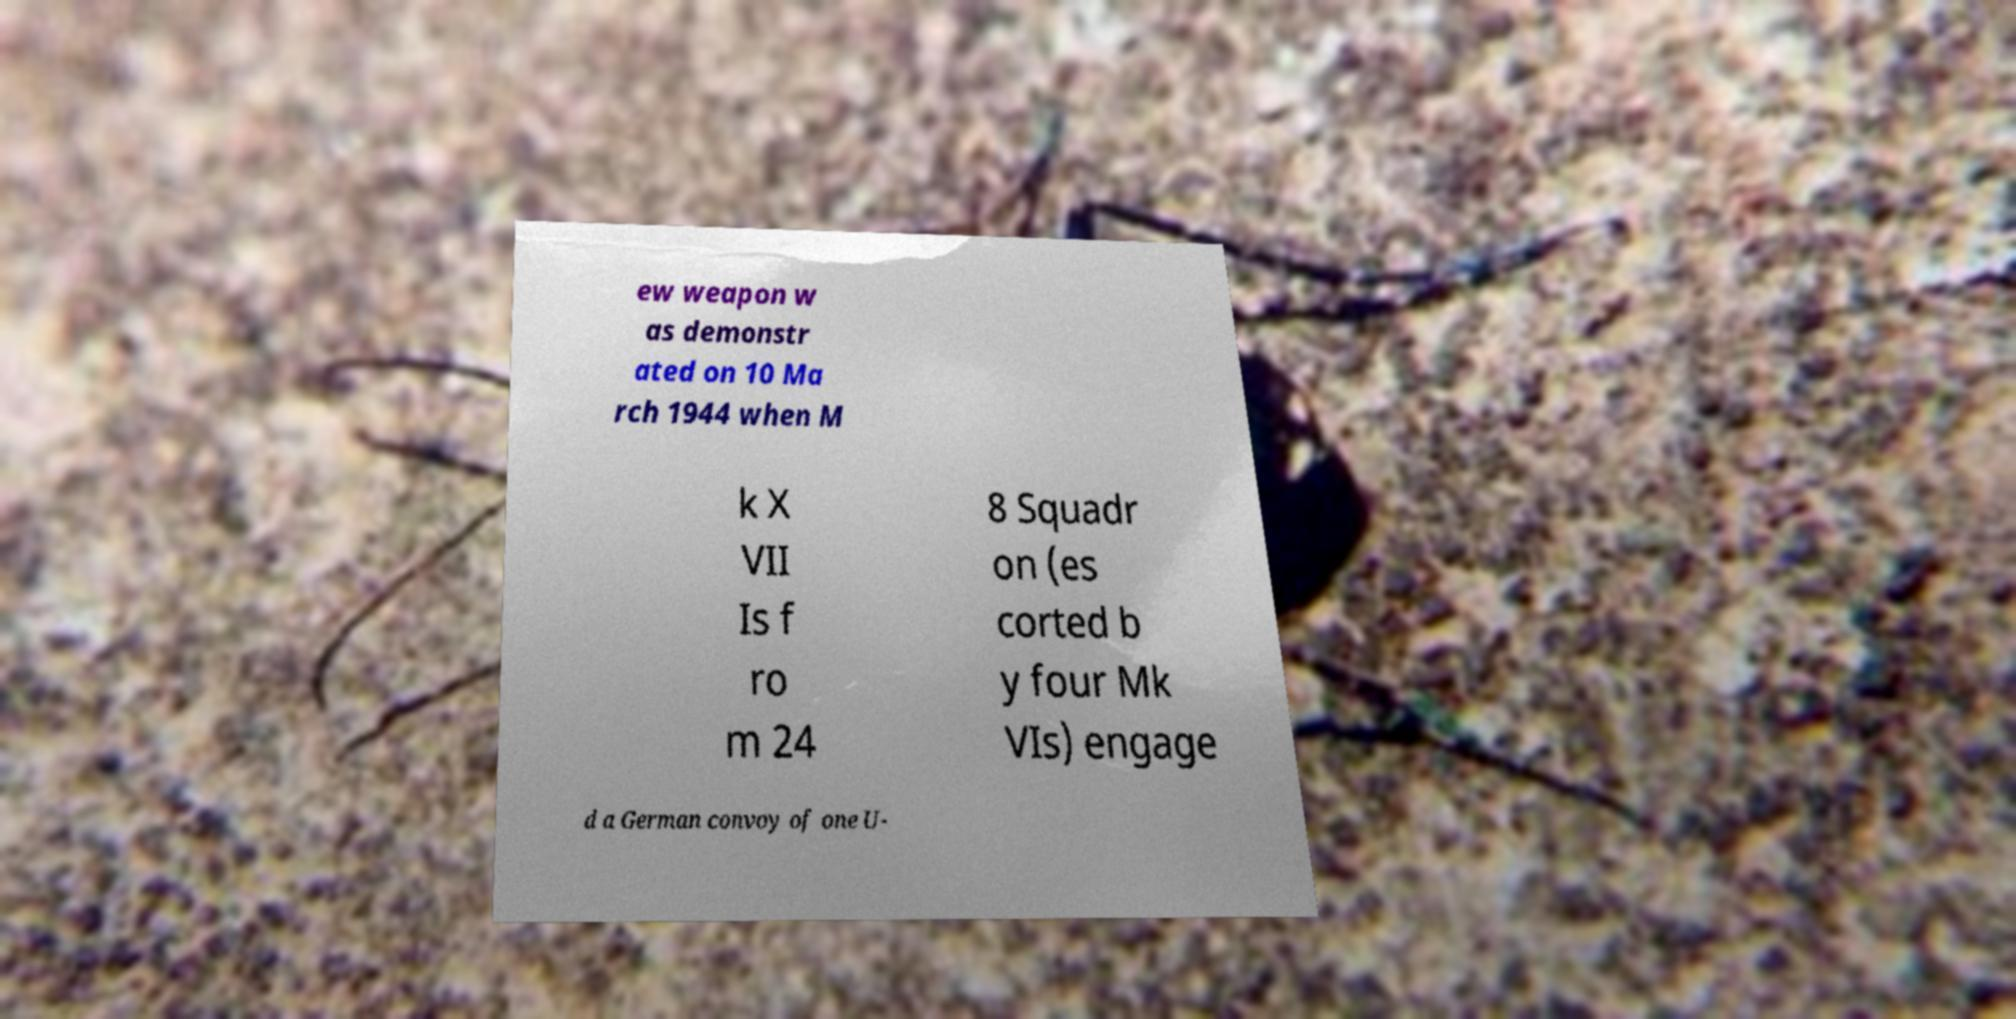There's text embedded in this image that I need extracted. Can you transcribe it verbatim? ew weapon w as demonstr ated on 10 Ma rch 1944 when M k X VII Is f ro m 24 8 Squadr on (es corted b y four Mk VIs) engage d a German convoy of one U- 